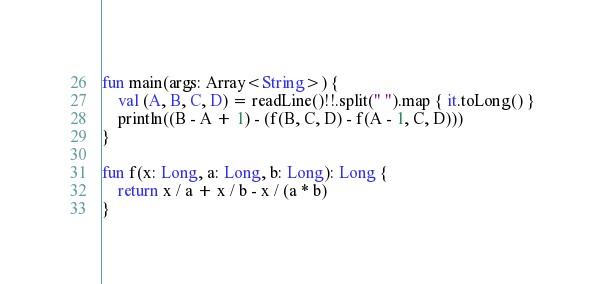<code> <loc_0><loc_0><loc_500><loc_500><_Kotlin_>fun main(args: Array<String>) {
    val (A, B, C, D) = readLine()!!.split(" ").map { it.toLong() }
    println((B - A + 1) - (f(B, C, D) - f(A - 1, C, D)))
}

fun f(x: Long, a: Long, b: Long): Long {
    return x / a + x / b - x / (a * b)
}</code> 